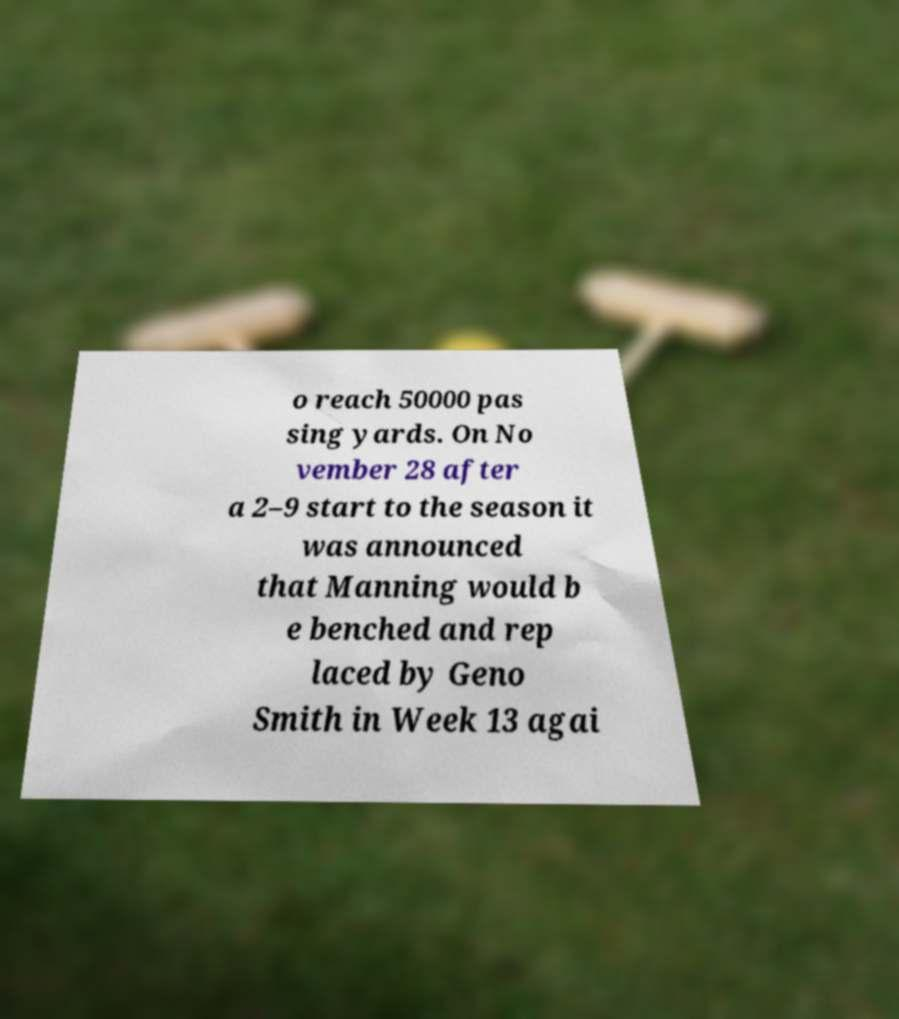There's text embedded in this image that I need extracted. Can you transcribe it verbatim? o reach 50000 pas sing yards. On No vember 28 after a 2–9 start to the season it was announced that Manning would b e benched and rep laced by Geno Smith in Week 13 agai 